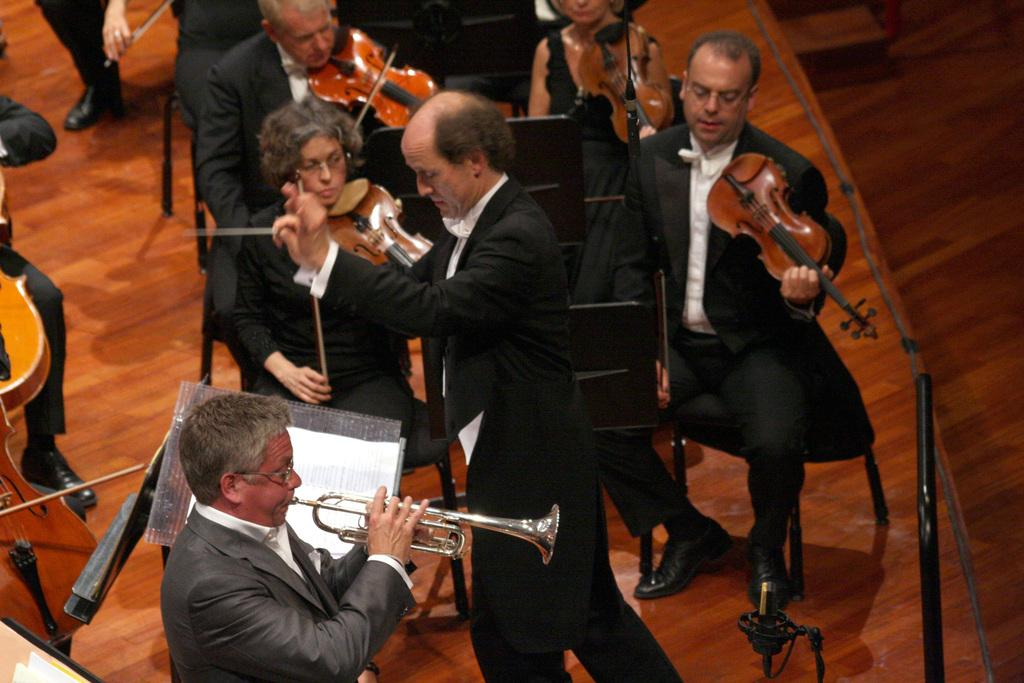What is happening in the image? There are people in the image, and they are playing musical instruments. What are the people doing specifically? The people are playing musical instruments, which suggests they might be in a band or participating in a musical performance. What type of basketball is being folded by the people in the image? There is no basketball present in the image; the people are playing musical instruments. 